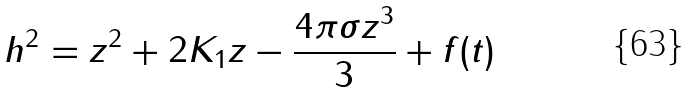Convert formula to latex. <formula><loc_0><loc_0><loc_500><loc_500>h ^ { 2 } = z ^ { 2 } + 2 K _ { 1 } z - \frac { 4 { \pi } { \sigma } z ^ { 3 } } { 3 } + f ( t )</formula> 